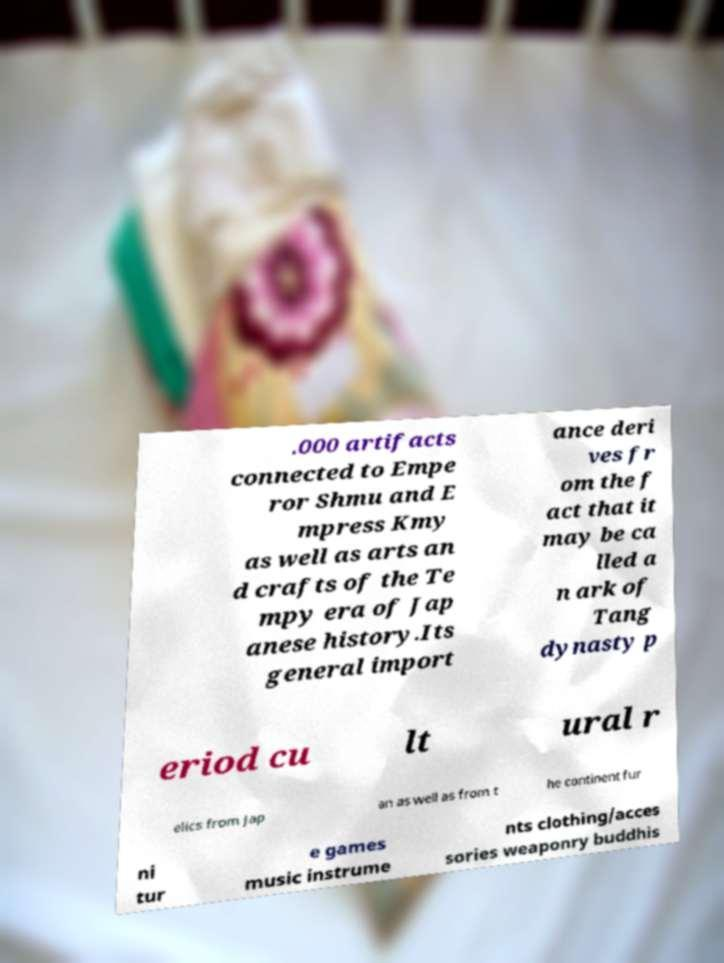What messages or text are displayed in this image? I need them in a readable, typed format. .000 artifacts connected to Empe ror Shmu and E mpress Kmy as well as arts an d crafts of the Te mpy era of Jap anese history.Its general import ance deri ves fr om the f act that it may be ca lled a n ark of Tang dynasty p eriod cu lt ural r elics from Jap an as well as from t he continent fur ni tur e games music instrume nts clothing/acces sories weaponry buddhis 